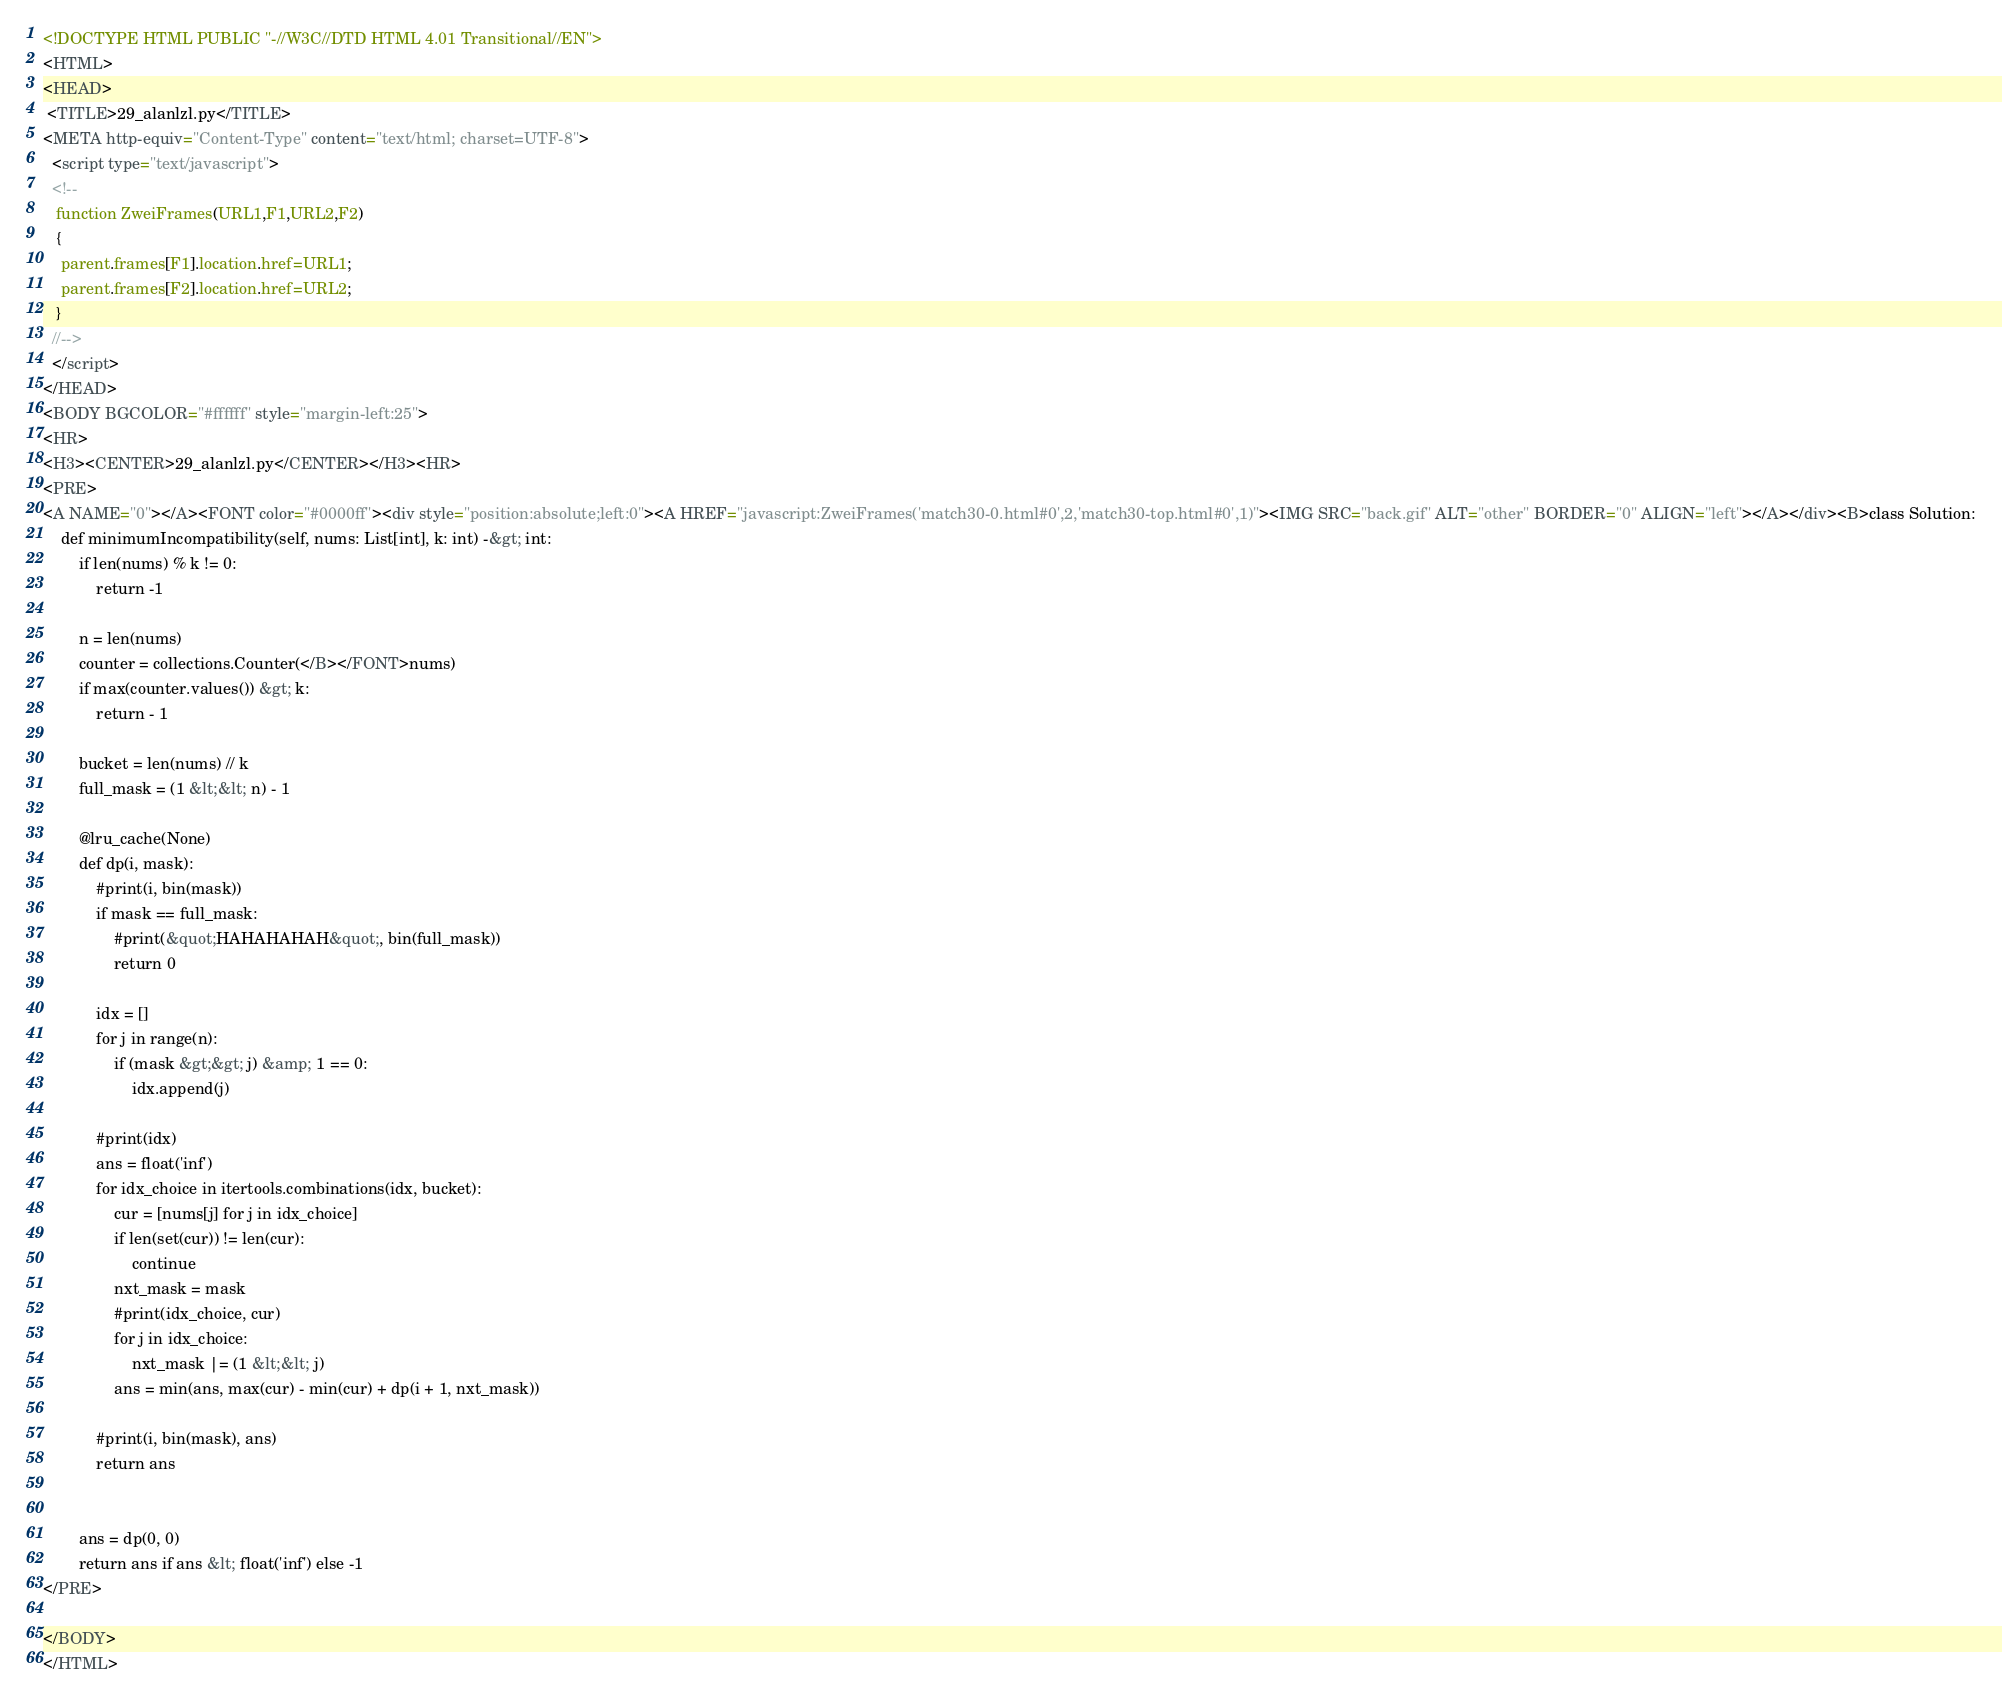<code> <loc_0><loc_0><loc_500><loc_500><_HTML_><!DOCTYPE HTML PUBLIC "-//W3C//DTD HTML 4.01 Transitional//EN">
<HTML>
<HEAD>
 <TITLE>29_alanlzl.py</TITLE>
<META http-equiv="Content-Type" content="text/html; charset=UTF-8">
  <script type="text/javascript">
  <!--
   function ZweiFrames(URL1,F1,URL2,F2)
   {
    parent.frames[F1].location.href=URL1;
    parent.frames[F2].location.href=URL2;
   }
  //-->
  </script>
</HEAD>
<BODY BGCOLOR="#ffffff" style="margin-left:25">
<HR>
<H3><CENTER>29_alanlzl.py</CENTER></H3><HR>
<PRE>
<A NAME="0"></A><FONT color="#0000ff"><div style="position:absolute;left:0"><A HREF="javascript:ZweiFrames('match30-0.html#0',2,'match30-top.html#0',1)"><IMG SRC="back.gif" ALT="other" BORDER="0" ALIGN="left"></A></div><B>class Solution:
    def minimumIncompatibility(self, nums: List[int], k: int) -&gt; int:
        if len(nums) % k != 0:
            return -1
        
        n = len(nums)
        counter = collections.Counter(</B></FONT>nums)
        if max(counter.values()) &gt; k:
            return - 1
        
        bucket = len(nums) // k
        full_mask = (1 &lt;&lt; n) - 1
        
        @lru_cache(None)
        def dp(i, mask):
            #print(i, bin(mask))
            if mask == full_mask:
                #print(&quot;HAHAHAHAH&quot;, bin(full_mask))
                return 0
            
            idx = []
            for j in range(n):
                if (mask &gt;&gt; j) &amp; 1 == 0:
                    idx.append(j)
            
            #print(idx)
            ans = float('inf')
            for idx_choice in itertools.combinations(idx, bucket):
                cur = [nums[j] for j in idx_choice]
                if len(set(cur)) != len(cur):
                    continue
                nxt_mask = mask
                #print(idx_choice, cur)
                for j in idx_choice:
                    nxt_mask |= (1 &lt;&lt; j)
                ans = min(ans, max(cur) - min(cur) + dp(i + 1, nxt_mask))
            
            #print(i, bin(mask), ans)
            return ans
                    
                
        ans = dp(0, 0)
        return ans if ans &lt; float('inf') else -1 
</PRE>

</BODY>
</HTML>
</code> 